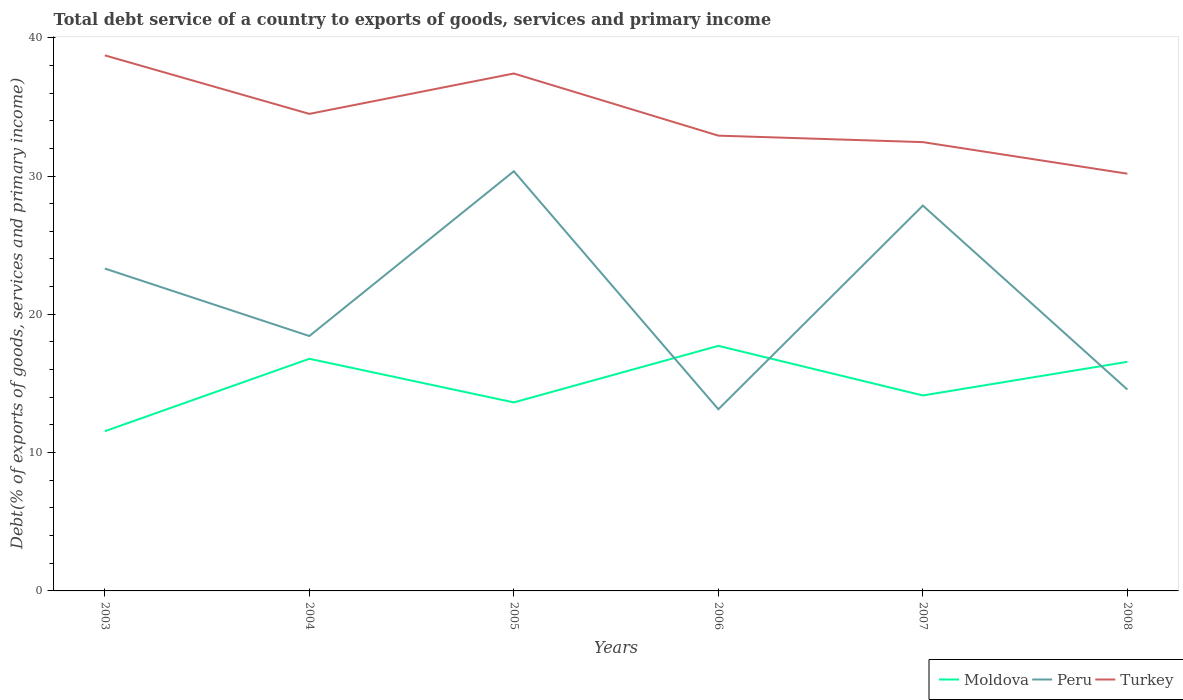How many different coloured lines are there?
Your answer should be compact. 3. Does the line corresponding to Turkey intersect with the line corresponding to Moldova?
Provide a succinct answer. No. Is the number of lines equal to the number of legend labels?
Provide a short and direct response. Yes. Across all years, what is the maximum total debt service in Moldova?
Ensure brevity in your answer.  11.55. In which year was the total debt service in Moldova maximum?
Offer a very short reply. 2003. What is the total total debt service in Moldova in the graph?
Offer a very short reply. -0.93. What is the difference between the highest and the second highest total debt service in Moldova?
Provide a succinct answer. 6.17. What is the difference between the highest and the lowest total debt service in Turkey?
Your answer should be compact. 3. How many years are there in the graph?
Your answer should be compact. 6. What is the difference between two consecutive major ticks on the Y-axis?
Ensure brevity in your answer.  10. Does the graph contain grids?
Keep it short and to the point. No. How many legend labels are there?
Give a very brief answer. 3. How are the legend labels stacked?
Provide a short and direct response. Horizontal. What is the title of the graph?
Provide a succinct answer. Total debt service of a country to exports of goods, services and primary income. What is the label or title of the Y-axis?
Offer a terse response. Debt(% of exports of goods, services and primary income). What is the Debt(% of exports of goods, services and primary income) in Moldova in 2003?
Your answer should be compact. 11.55. What is the Debt(% of exports of goods, services and primary income) of Peru in 2003?
Your response must be concise. 23.31. What is the Debt(% of exports of goods, services and primary income) in Turkey in 2003?
Make the answer very short. 38.72. What is the Debt(% of exports of goods, services and primary income) in Moldova in 2004?
Your response must be concise. 16.79. What is the Debt(% of exports of goods, services and primary income) in Peru in 2004?
Make the answer very short. 18.43. What is the Debt(% of exports of goods, services and primary income) of Turkey in 2004?
Keep it short and to the point. 34.49. What is the Debt(% of exports of goods, services and primary income) of Moldova in 2005?
Your answer should be very brief. 13.63. What is the Debt(% of exports of goods, services and primary income) of Peru in 2005?
Ensure brevity in your answer.  30.35. What is the Debt(% of exports of goods, services and primary income) of Turkey in 2005?
Your answer should be very brief. 37.41. What is the Debt(% of exports of goods, services and primary income) in Moldova in 2006?
Keep it short and to the point. 17.72. What is the Debt(% of exports of goods, services and primary income) in Peru in 2006?
Keep it short and to the point. 13.13. What is the Debt(% of exports of goods, services and primary income) of Turkey in 2006?
Your answer should be compact. 32.92. What is the Debt(% of exports of goods, services and primary income) in Moldova in 2007?
Your answer should be compact. 14.13. What is the Debt(% of exports of goods, services and primary income) in Peru in 2007?
Provide a succinct answer. 27.86. What is the Debt(% of exports of goods, services and primary income) in Turkey in 2007?
Offer a terse response. 32.45. What is the Debt(% of exports of goods, services and primary income) of Moldova in 2008?
Your answer should be compact. 16.56. What is the Debt(% of exports of goods, services and primary income) of Peru in 2008?
Offer a terse response. 14.56. What is the Debt(% of exports of goods, services and primary income) of Turkey in 2008?
Offer a terse response. 30.17. Across all years, what is the maximum Debt(% of exports of goods, services and primary income) of Moldova?
Offer a terse response. 17.72. Across all years, what is the maximum Debt(% of exports of goods, services and primary income) of Peru?
Offer a terse response. 30.35. Across all years, what is the maximum Debt(% of exports of goods, services and primary income) in Turkey?
Make the answer very short. 38.72. Across all years, what is the minimum Debt(% of exports of goods, services and primary income) of Moldova?
Offer a very short reply. 11.55. Across all years, what is the minimum Debt(% of exports of goods, services and primary income) of Peru?
Make the answer very short. 13.13. Across all years, what is the minimum Debt(% of exports of goods, services and primary income) of Turkey?
Your answer should be compact. 30.17. What is the total Debt(% of exports of goods, services and primary income) of Moldova in the graph?
Offer a very short reply. 90.38. What is the total Debt(% of exports of goods, services and primary income) in Peru in the graph?
Offer a very short reply. 127.64. What is the total Debt(% of exports of goods, services and primary income) in Turkey in the graph?
Provide a succinct answer. 206.17. What is the difference between the Debt(% of exports of goods, services and primary income) of Moldova in 2003 and that in 2004?
Keep it short and to the point. -5.24. What is the difference between the Debt(% of exports of goods, services and primary income) of Peru in 2003 and that in 2004?
Your answer should be very brief. 4.88. What is the difference between the Debt(% of exports of goods, services and primary income) of Turkey in 2003 and that in 2004?
Ensure brevity in your answer.  4.23. What is the difference between the Debt(% of exports of goods, services and primary income) in Moldova in 2003 and that in 2005?
Your answer should be compact. -2.08. What is the difference between the Debt(% of exports of goods, services and primary income) in Peru in 2003 and that in 2005?
Keep it short and to the point. -7.04. What is the difference between the Debt(% of exports of goods, services and primary income) in Turkey in 2003 and that in 2005?
Provide a short and direct response. 1.31. What is the difference between the Debt(% of exports of goods, services and primary income) in Moldova in 2003 and that in 2006?
Your answer should be very brief. -6.17. What is the difference between the Debt(% of exports of goods, services and primary income) in Peru in 2003 and that in 2006?
Offer a very short reply. 10.18. What is the difference between the Debt(% of exports of goods, services and primary income) of Turkey in 2003 and that in 2006?
Keep it short and to the point. 5.8. What is the difference between the Debt(% of exports of goods, services and primary income) in Moldova in 2003 and that in 2007?
Keep it short and to the point. -2.59. What is the difference between the Debt(% of exports of goods, services and primary income) of Peru in 2003 and that in 2007?
Your answer should be very brief. -4.55. What is the difference between the Debt(% of exports of goods, services and primary income) of Turkey in 2003 and that in 2007?
Give a very brief answer. 6.27. What is the difference between the Debt(% of exports of goods, services and primary income) in Moldova in 2003 and that in 2008?
Ensure brevity in your answer.  -5.02. What is the difference between the Debt(% of exports of goods, services and primary income) of Peru in 2003 and that in 2008?
Make the answer very short. 8.75. What is the difference between the Debt(% of exports of goods, services and primary income) of Turkey in 2003 and that in 2008?
Provide a short and direct response. 8.56. What is the difference between the Debt(% of exports of goods, services and primary income) of Moldova in 2004 and that in 2005?
Give a very brief answer. 3.15. What is the difference between the Debt(% of exports of goods, services and primary income) of Peru in 2004 and that in 2005?
Offer a terse response. -11.91. What is the difference between the Debt(% of exports of goods, services and primary income) in Turkey in 2004 and that in 2005?
Provide a succinct answer. -2.92. What is the difference between the Debt(% of exports of goods, services and primary income) in Moldova in 2004 and that in 2006?
Give a very brief answer. -0.93. What is the difference between the Debt(% of exports of goods, services and primary income) in Peru in 2004 and that in 2006?
Ensure brevity in your answer.  5.3. What is the difference between the Debt(% of exports of goods, services and primary income) of Turkey in 2004 and that in 2006?
Make the answer very short. 1.57. What is the difference between the Debt(% of exports of goods, services and primary income) in Moldova in 2004 and that in 2007?
Offer a terse response. 2.65. What is the difference between the Debt(% of exports of goods, services and primary income) in Peru in 2004 and that in 2007?
Give a very brief answer. -9.43. What is the difference between the Debt(% of exports of goods, services and primary income) of Turkey in 2004 and that in 2007?
Provide a short and direct response. 2.04. What is the difference between the Debt(% of exports of goods, services and primary income) in Moldova in 2004 and that in 2008?
Provide a succinct answer. 0.22. What is the difference between the Debt(% of exports of goods, services and primary income) in Peru in 2004 and that in 2008?
Keep it short and to the point. 3.87. What is the difference between the Debt(% of exports of goods, services and primary income) in Turkey in 2004 and that in 2008?
Provide a succinct answer. 4.33. What is the difference between the Debt(% of exports of goods, services and primary income) in Moldova in 2005 and that in 2006?
Offer a very short reply. -4.09. What is the difference between the Debt(% of exports of goods, services and primary income) in Peru in 2005 and that in 2006?
Provide a succinct answer. 17.21. What is the difference between the Debt(% of exports of goods, services and primary income) of Turkey in 2005 and that in 2006?
Provide a short and direct response. 4.49. What is the difference between the Debt(% of exports of goods, services and primary income) in Moldova in 2005 and that in 2007?
Offer a very short reply. -0.5. What is the difference between the Debt(% of exports of goods, services and primary income) of Peru in 2005 and that in 2007?
Provide a succinct answer. 2.48. What is the difference between the Debt(% of exports of goods, services and primary income) of Turkey in 2005 and that in 2007?
Your response must be concise. 4.96. What is the difference between the Debt(% of exports of goods, services and primary income) of Moldova in 2005 and that in 2008?
Keep it short and to the point. -2.93. What is the difference between the Debt(% of exports of goods, services and primary income) of Peru in 2005 and that in 2008?
Ensure brevity in your answer.  15.79. What is the difference between the Debt(% of exports of goods, services and primary income) in Turkey in 2005 and that in 2008?
Give a very brief answer. 7.25. What is the difference between the Debt(% of exports of goods, services and primary income) in Moldova in 2006 and that in 2007?
Your answer should be compact. 3.59. What is the difference between the Debt(% of exports of goods, services and primary income) in Peru in 2006 and that in 2007?
Make the answer very short. -14.73. What is the difference between the Debt(% of exports of goods, services and primary income) of Turkey in 2006 and that in 2007?
Give a very brief answer. 0.47. What is the difference between the Debt(% of exports of goods, services and primary income) of Moldova in 2006 and that in 2008?
Offer a very short reply. 1.16. What is the difference between the Debt(% of exports of goods, services and primary income) in Peru in 2006 and that in 2008?
Give a very brief answer. -1.43. What is the difference between the Debt(% of exports of goods, services and primary income) in Turkey in 2006 and that in 2008?
Your response must be concise. 2.75. What is the difference between the Debt(% of exports of goods, services and primary income) in Moldova in 2007 and that in 2008?
Ensure brevity in your answer.  -2.43. What is the difference between the Debt(% of exports of goods, services and primary income) in Peru in 2007 and that in 2008?
Your answer should be compact. 13.3. What is the difference between the Debt(% of exports of goods, services and primary income) of Turkey in 2007 and that in 2008?
Offer a very short reply. 2.28. What is the difference between the Debt(% of exports of goods, services and primary income) of Moldova in 2003 and the Debt(% of exports of goods, services and primary income) of Peru in 2004?
Keep it short and to the point. -6.88. What is the difference between the Debt(% of exports of goods, services and primary income) of Moldova in 2003 and the Debt(% of exports of goods, services and primary income) of Turkey in 2004?
Provide a short and direct response. -22.95. What is the difference between the Debt(% of exports of goods, services and primary income) in Peru in 2003 and the Debt(% of exports of goods, services and primary income) in Turkey in 2004?
Your response must be concise. -11.18. What is the difference between the Debt(% of exports of goods, services and primary income) of Moldova in 2003 and the Debt(% of exports of goods, services and primary income) of Peru in 2005?
Give a very brief answer. -18.8. What is the difference between the Debt(% of exports of goods, services and primary income) of Moldova in 2003 and the Debt(% of exports of goods, services and primary income) of Turkey in 2005?
Your response must be concise. -25.87. What is the difference between the Debt(% of exports of goods, services and primary income) of Peru in 2003 and the Debt(% of exports of goods, services and primary income) of Turkey in 2005?
Provide a short and direct response. -14.1. What is the difference between the Debt(% of exports of goods, services and primary income) in Moldova in 2003 and the Debt(% of exports of goods, services and primary income) in Peru in 2006?
Provide a succinct answer. -1.59. What is the difference between the Debt(% of exports of goods, services and primary income) in Moldova in 2003 and the Debt(% of exports of goods, services and primary income) in Turkey in 2006?
Offer a terse response. -21.37. What is the difference between the Debt(% of exports of goods, services and primary income) in Peru in 2003 and the Debt(% of exports of goods, services and primary income) in Turkey in 2006?
Offer a very short reply. -9.61. What is the difference between the Debt(% of exports of goods, services and primary income) of Moldova in 2003 and the Debt(% of exports of goods, services and primary income) of Peru in 2007?
Provide a short and direct response. -16.31. What is the difference between the Debt(% of exports of goods, services and primary income) of Moldova in 2003 and the Debt(% of exports of goods, services and primary income) of Turkey in 2007?
Provide a short and direct response. -20.9. What is the difference between the Debt(% of exports of goods, services and primary income) of Peru in 2003 and the Debt(% of exports of goods, services and primary income) of Turkey in 2007?
Your answer should be compact. -9.14. What is the difference between the Debt(% of exports of goods, services and primary income) of Moldova in 2003 and the Debt(% of exports of goods, services and primary income) of Peru in 2008?
Provide a succinct answer. -3.01. What is the difference between the Debt(% of exports of goods, services and primary income) in Moldova in 2003 and the Debt(% of exports of goods, services and primary income) in Turkey in 2008?
Ensure brevity in your answer.  -18.62. What is the difference between the Debt(% of exports of goods, services and primary income) of Peru in 2003 and the Debt(% of exports of goods, services and primary income) of Turkey in 2008?
Your answer should be very brief. -6.86. What is the difference between the Debt(% of exports of goods, services and primary income) of Moldova in 2004 and the Debt(% of exports of goods, services and primary income) of Peru in 2005?
Provide a succinct answer. -13.56. What is the difference between the Debt(% of exports of goods, services and primary income) in Moldova in 2004 and the Debt(% of exports of goods, services and primary income) in Turkey in 2005?
Your answer should be very brief. -20.63. What is the difference between the Debt(% of exports of goods, services and primary income) in Peru in 2004 and the Debt(% of exports of goods, services and primary income) in Turkey in 2005?
Keep it short and to the point. -18.98. What is the difference between the Debt(% of exports of goods, services and primary income) of Moldova in 2004 and the Debt(% of exports of goods, services and primary income) of Peru in 2006?
Your answer should be compact. 3.65. What is the difference between the Debt(% of exports of goods, services and primary income) of Moldova in 2004 and the Debt(% of exports of goods, services and primary income) of Turkey in 2006?
Provide a short and direct response. -16.13. What is the difference between the Debt(% of exports of goods, services and primary income) in Peru in 2004 and the Debt(% of exports of goods, services and primary income) in Turkey in 2006?
Your answer should be compact. -14.49. What is the difference between the Debt(% of exports of goods, services and primary income) of Moldova in 2004 and the Debt(% of exports of goods, services and primary income) of Peru in 2007?
Ensure brevity in your answer.  -11.08. What is the difference between the Debt(% of exports of goods, services and primary income) in Moldova in 2004 and the Debt(% of exports of goods, services and primary income) in Turkey in 2007?
Make the answer very short. -15.67. What is the difference between the Debt(% of exports of goods, services and primary income) of Peru in 2004 and the Debt(% of exports of goods, services and primary income) of Turkey in 2007?
Offer a terse response. -14.02. What is the difference between the Debt(% of exports of goods, services and primary income) of Moldova in 2004 and the Debt(% of exports of goods, services and primary income) of Peru in 2008?
Ensure brevity in your answer.  2.23. What is the difference between the Debt(% of exports of goods, services and primary income) in Moldova in 2004 and the Debt(% of exports of goods, services and primary income) in Turkey in 2008?
Offer a very short reply. -13.38. What is the difference between the Debt(% of exports of goods, services and primary income) of Peru in 2004 and the Debt(% of exports of goods, services and primary income) of Turkey in 2008?
Offer a terse response. -11.74. What is the difference between the Debt(% of exports of goods, services and primary income) of Moldova in 2005 and the Debt(% of exports of goods, services and primary income) of Peru in 2006?
Your answer should be compact. 0.5. What is the difference between the Debt(% of exports of goods, services and primary income) in Moldova in 2005 and the Debt(% of exports of goods, services and primary income) in Turkey in 2006?
Provide a succinct answer. -19.29. What is the difference between the Debt(% of exports of goods, services and primary income) of Peru in 2005 and the Debt(% of exports of goods, services and primary income) of Turkey in 2006?
Make the answer very short. -2.57. What is the difference between the Debt(% of exports of goods, services and primary income) of Moldova in 2005 and the Debt(% of exports of goods, services and primary income) of Peru in 2007?
Provide a short and direct response. -14.23. What is the difference between the Debt(% of exports of goods, services and primary income) of Moldova in 2005 and the Debt(% of exports of goods, services and primary income) of Turkey in 2007?
Give a very brief answer. -18.82. What is the difference between the Debt(% of exports of goods, services and primary income) in Peru in 2005 and the Debt(% of exports of goods, services and primary income) in Turkey in 2007?
Ensure brevity in your answer.  -2.11. What is the difference between the Debt(% of exports of goods, services and primary income) in Moldova in 2005 and the Debt(% of exports of goods, services and primary income) in Peru in 2008?
Give a very brief answer. -0.93. What is the difference between the Debt(% of exports of goods, services and primary income) of Moldova in 2005 and the Debt(% of exports of goods, services and primary income) of Turkey in 2008?
Make the answer very short. -16.54. What is the difference between the Debt(% of exports of goods, services and primary income) of Peru in 2005 and the Debt(% of exports of goods, services and primary income) of Turkey in 2008?
Make the answer very short. 0.18. What is the difference between the Debt(% of exports of goods, services and primary income) in Moldova in 2006 and the Debt(% of exports of goods, services and primary income) in Peru in 2007?
Provide a short and direct response. -10.14. What is the difference between the Debt(% of exports of goods, services and primary income) of Moldova in 2006 and the Debt(% of exports of goods, services and primary income) of Turkey in 2007?
Provide a succinct answer. -14.73. What is the difference between the Debt(% of exports of goods, services and primary income) of Peru in 2006 and the Debt(% of exports of goods, services and primary income) of Turkey in 2007?
Your answer should be compact. -19.32. What is the difference between the Debt(% of exports of goods, services and primary income) in Moldova in 2006 and the Debt(% of exports of goods, services and primary income) in Peru in 2008?
Your answer should be compact. 3.16. What is the difference between the Debt(% of exports of goods, services and primary income) in Moldova in 2006 and the Debt(% of exports of goods, services and primary income) in Turkey in 2008?
Your response must be concise. -12.45. What is the difference between the Debt(% of exports of goods, services and primary income) of Peru in 2006 and the Debt(% of exports of goods, services and primary income) of Turkey in 2008?
Ensure brevity in your answer.  -17.03. What is the difference between the Debt(% of exports of goods, services and primary income) of Moldova in 2007 and the Debt(% of exports of goods, services and primary income) of Peru in 2008?
Provide a short and direct response. -0.43. What is the difference between the Debt(% of exports of goods, services and primary income) of Moldova in 2007 and the Debt(% of exports of goods, services and primary income) of Turkey in 2008?
Provide a succinct answer. -16.03. What is the difference between the Debt(% of exports of goods, services and primary income) in Peru in 2007 and the Debt(% of exports of goods, services and primary income) in Turkey in 2008?
Your answer should be compact. -2.31. What is the average Debt(% of exports of goods, services and primary income) in Moldova per year?
Offer a very short reply. 15.06. What is the average Debt(% of exports of goods, services and primary income) of Peru per year?
Provide a succinct answer. 21.27. What is the average Debt(% of exports of goods, services and primary income) of Turkey per year?
Make the answer very short. 34.36. In the year 2003, what is the difference between the Debt(% of exports of goods, services and primary income) in Moldova and Debt(% of exports of goods, services and primary income) in Peru?
Your response must be concise. -11.76. In the year 2003, what is the difference between the Debt(% of exports of goods, services and primary income) of Moldova and Debt(% of exports of goods, services and primary income) of Turkey?
Ensure brevity in your answer.  -27.18. In the year 2003, what is the difference between the Debt(% of exports of goods, services and primary income) of Peru and Debt(% of exports of goods, services and primary income) of Turkey?
Offer a terse response. -15.41. In the year 2004, what is the difference between the Debt(% of exports of goods, services and primary income) of Moldova and Debt(% of exports of goods, services and primary income) of Peru?
Your response must be concise. -1.65. In the year 2004, what is the difference between the Debt(% of exports of goods, services and primary income) in Moldova and Debt(% of exports of goods, services and primary income) in Turkey?
Keep it short and to the point. -17.71. In the year 2004, what is the difference between the Debt(% of exports of goods, services and primary income) of Peru and Debt(% of exports of goods, services and primary income) of Turkey?
Your answer should be compact. -16.06. In the year 2005, what is the difference between the Debt(% of exports of goods, services and primary income) of Moldova and Debt(% of exports of goods, services and primary income) of Peru?
Your answer should be compact. -16.71. In the year 2005, what is the difference between the Debt(% of exports of goods, services and primary income) of Moldova and Debt(% of exports of goods, services and primary income) of Turkey?
Make the answer very short. -23.78. In the year 2005, what is the difference between the Debt(% of exports of goods, services and primary income) of Peru and Debt(% of exports of goods, services and primary income) of Turkey?
Make the answer very short. -7.07. In the year 2006, what is the difference between the Debt(% of exports of goods, services and primary income) of Moldova and Debt(% of exports of goods, services and primary income) of Peru?
Ensure brevity in your answer.  4.59. In the year 2006, what is the difference between the Debt(% of exports of goods, services and primary income) in Moldova and Debt(% of exports of goods, services and primary income) in Turkey?
Give a very brief answer. -15.2. In the year 2006, what is the difference between the Debt(% of exports of goods, services and primary income) of Peru and Debt(% of exports of goods, services and primary income) of Turkey?
Keep it short and to the point. -19.79. In the year 2007, what is the difference between the Debt(% of exports of goods, services and primary income) in Moldova and Debt(% of exports of goods, services and primary income) in Peru?
Provide a short and direct response. -13.73. In the year 2007, what is the difference between the Debt(% of exports of goods, services and primary income) of Moldova and Debt(% of exports of goods, services and primary income) of Turkey?
Make the answer very short. -18.32. In the year 2007, what is the difference between the Debt(% of exports of goods, services and primary income) in Peru and Debt(% of exports of goods, services and primary income) in Turkey?
Keep it short and to the point. -4.59. In the year 2008, what is the difference between the Debt(% of exports of goods, services and primary income) of Moldova and Debt(% of exports of goods, services and primary income) of Peru?
Offer a very short reply. 2. In the year 2008, what is the difference between the Debt(% of exports of goods, services and primary income) in Moldova and Debt(% of exports of goods, services and primary income) in Turkey?
Offer a terse response. -13.6. In the year 2008, what is the difference between the Debt(% of exports of goods, services and primary income) of Peru and Debt(% of exports of goods, services and primary income) of Turkey?
Provide a short and direct response. -15.61. What is the ratio of the Debt(% of exports of goods, services and primary income) in Moldova in 2003 to that in 2004?
Offer a very short reply. 0.69. What is the ratio of the Debt(% of exports of goods, services and primary income) of Peru in 2003 to that in 2004?
Your response must be concise. 1.26. What is the ratio of the Debt(% of exports of goods, services and primary income) in Turkey in 2003 to that in 2004?
Offer a very short reply. 1.12. What is the ratio of the Debt(% of exports of goods, services and primary income) in Moldova in 2003 to that in 2005?
Provide a succinct answer. 0.85. What is the ratio of the Debt(% of exports of goods, services and primary income) of Peru in 2003 to that in 2005?
Ensure brevity in your answer.  0.77. What is the ratio of the Debt(% of exports of goods, services and primary income) in Turkey in 2003 to that in 2005?
Provide a succinct answer. 1.03. What is the ratio of the Debt(% of exports of goods, services and primary income) in Moldova in 2003 to that in 2006?
Make the answer very short. 0.65. What is the ratio of the Debt(% of exports of goods, services and primary income) in Peru in 2003 to that in 2006?
Offer a terse response. 1.77. What is the ratio of the Debt(% of exports of goods, services and primary income) in Turkey in 2003 to that in 2006?
Ensure brevity in your answer.  1.18. What is the ratio of the Debt(% of exports of goods, services and primary income) of Moldova in 2003 to that in 2007?
Give a very brief answer. 0.82. What is the ratio of the Debt(% of exports of goods, services and primary income) in Peru in 2003 to that in 2007?
Your answer should be very brief. 0.84. What is the ratio of the Debt(% of exports of goods, services and primary income) of Turkey in 2003 to that in 2007?
Provide a short and direct response. 1.19. What is the ratio of the Debt(% of exports of goods, services and primary income) in Moldova in 2003 to that in 2008?
Your response must be concise. 0.7. What is the ratio of the Debt(% of exports of goods, services and primary income) in Peru in 2003 to that in 2008?
Make the answer very short. 1.6. What is the ratio of the Debt(% of exports of goods, services and primary income) in Turkey in 2003 to that in 2008?
Offer a very short reply. 1.28. What is the ratio of the Debt(% of exports of goods, services and primary income) of Moldova in 2004 to that in 2005?
Offer a very short reply. 1.23. What is the ratio of the Debt(% of exports of goods, services and primary income) in Peru in 2004 to that in 2005?
Ensure brevity in your answer.  0.61. What is the ratio of the Debt(% of exports of goods, services and primary income) in Turkey in 2004 to that in 2005?
Make the answer very short. 0.92. What is the ratio of the Debt(% of exports of goods, services and primary income) of Moldova in 2004 to that in 2006?
Provide a short and direct response. 0.95. What is the ratio of the Debt(% of exports of goods, services and primary income) of Peru in 2004 to that in 2006?
Offer a very short reply. 1.4. What is the ratio of the Debt(% of exports of goods, services and primary income) of Turkey in 2004 to that in 2006?
Your answer should be very brief. 1.05. What is the ratio of the Debt(% of exports of goods, services and primary income) in Moldova in 2004 to that in 2007?
Your answer should be compact. 1.19. What is the ratio of the Debt(% of exports of goods, services and primary income) of Peru in 2004 to that in 2007?
Your response must be concise. 0.66. What is the ratio of the Debt(% of exports of goods, services and primary income) in Turkey in 2004 to that in 2007?
Offer a very short reply. 1.06. What is the ratio of the Debt(% of exports of goods, services and primary income) of Moldova in 2004 to that in 2008?
Keep it short and to the point. 1.01. What is the ratio of the Debt(% of exports of goods, services and primary income) in Peru in 2004 to that in 2008?
Offer a very short reply. 1.27. What is the ratio of the Debt(% of exports of goods, services and primary income) in Turkey in 2004 to that in 2008?
Provide a succinct answer. 1.14. What is the ratio of the Debt(% of exports of goods, services and primary income) in Moldova in 2005 to that in 2006?
Make the answer very short. 0.77. What is the ratio of the Debt(% of exports of goods, services and primary income) in Peru in 2005 to that in 2006?
Give a very brief answer. 2.31. What is the ratio of the Debt(% of exports of goods, services and primary income) of Turkey in 2005 to that in 2006?
Provide a succinct answer. 1.14. What is the ratio of the Debt(% of exports of goods, services and primary income) in Moldova in 2005 to that in 2007?
Your answer should be compact. 0.96. What is the ratio of the Debt(% of exports of goods, services and primary income) of Peru in 2005 to that in 2007?
Ensure brevity in your answer.  1.09. What is the ratio of the Debt(% of exports of goods, services and primary income) in Turkey in 2005 to that in 2007?
Your response must be concise. 1.15. What is the ratio of the Debt(% of exports of goods, services and primary income) in Moldova in 2005 to that in 2008?
Give a very brief answer. 0.82. What is the ratio of the Debt(% of exports of goods, services and primary income) in Peru in 2005 to that in 2008?
Your answer should be very brief. 2.08. What is the ratio of the Debt(% of exports of goods, services and primary income) in Turkey in 2005 to that in 2008?
Offer a very short reply. 1.24. What is the ratio of the Debt(% of exports of goods, services and primary income) of Moldova in 2006 to that in 2007?
Offer a very short reply. 1.25. What is the ratio of the Debt(% of exports of goods, services and primary income) in Peru in 2006 to that in 2007?
Offer a terse response. 0.47. What is the ratio of the Debt(% of exports of goods, services and primary income) in Turkey in 2006 to that in 2007?
Give a very brief answer. 1.01. What is the ratio of the Debt(% of exports of goods, services and primary income) of Moldova in 2006 to that in 2008?
Give a very brief answer. 1.07. What is the ratio of the Debt(% of exports of goods, services and primary income) in Peru in 2006 to that in 2008?
Your response must be concise. 0.9. What is the ratio of the Debt(% of exports of goods, services and primary income) of Turkey in 2006 to that in 2008?
Keep it short and to the point. 1.09. What is the ratio of the Debt(% of exports of goods, services and primary income) of Moldova in 2007 to that in 2008?
Ensure brevity in your answer.  0.85. What is the ratio of the Debt(% of exports of goods, services and primary income) of Peru in 2007 to that in 2008?
Offer a terse response. 1.91. What is the ratio of the Debt(% of exports of goods, services and primary income) of Turkey in 2007 to that in 2008?
Your answer should be very brief. 1.08. What is the difference between the highest and the second highest Debt(% of exports of goods, services and primary income) in Moldova?
Offer a very short reply. 0.93. What is the difference between the highest and the second highest Debt(% of exports of goods, services and primary income) in Peru?
Give a very brief answer. 2.48. What is the difference between the highest and the second highest Debt(% of exports of goods, services and primary income) in Turkey?
Provide a short and direct response. 1.31. What is the difference between the highest and the lowest Debt(% of exports of goods, services and primary income) in Moldova?
Give a very brief answer. 6.17. What is the difference between the highest and the lowest Debt(% of exports of goods, services and primary income) of Peru?
Provide a short and direct response. 17.21. What is the difference between the highest and the lowest Debt(% of exports of goods, services and primary income) of Turkey?
Your response must be concise. 8.56. 